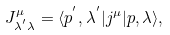Convert formula to latex. <formula><loc_0><loc_0><loc_500><loc_500>J ^ { \mu } _ { \lambda ^ { ^ { \prime } } \lambda } = \langle p ^ { ^ { \prime } } , \lambda ^ { ^ { \prime } } | j ^ { \mu } | p , \lambda \rangle ,</formula> 